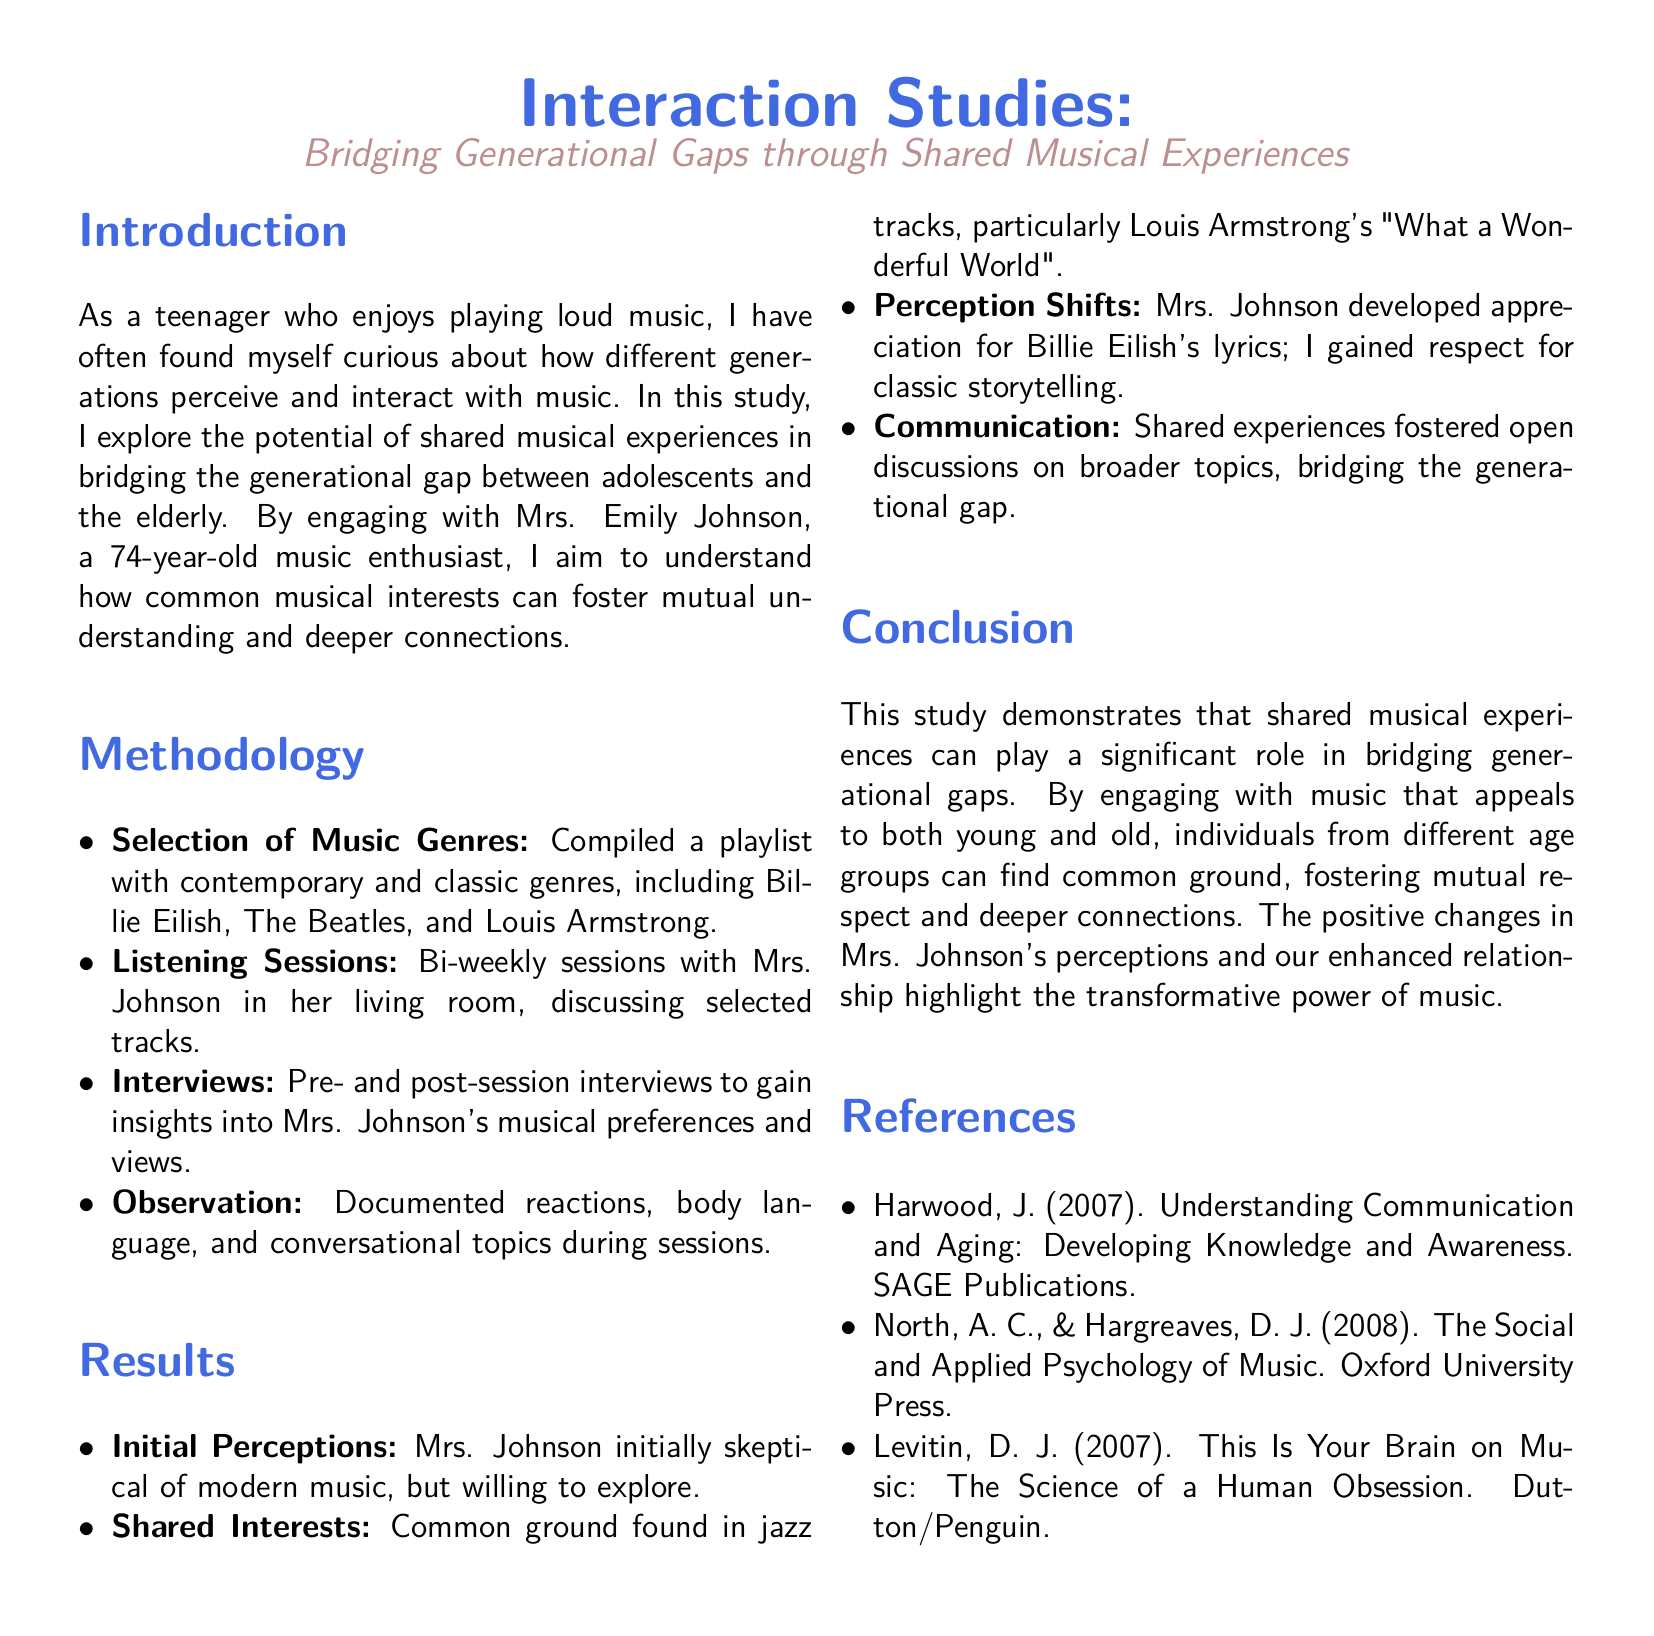What is the title of the study? The title is the main heading of the document and summarizes the focus of the research on music and generational gaps.
Answer: Interaction Studies: Bridging Generational Gaps through Shared Musical Experiences Who is the elderly woman the researcher engages with? The name is mentioned in the introduction section of the report, highlighting her importance in the study.
Answer: Mrs. Emily Johnson What genre of music initially raised skepticism? The document mentions the change in Mrs. Johnson's opinion regarding modern music, which began with skepticism.
Answer: Modern music What bi-weekly activity did the researcher conduct with Mrs. Johnson? This activity is outlined in the methodology section as a regular engagement to discuss music.
Answer: Listening Sessions What was a common track they found interest in? The results section specifies a particular song that bridged their musical preferences.
Answer: What a Wonderful World What is one positive outcome mentioned in the study? This conclusion reflects on the improvement in relationships and understanding based on shared music experiences.
Answer: Deeper connections How many references are included in the document? The references section shows the sources that supported the study, indicating academic rigor in the exploration.
Answer: Three What shift occurred in Mrs. Johnson's perception regarding Billie Eilish? This aspect of her changing views is highlighted in the results, regarding her acceptance of contemporary lyrics.
Answer: Appreciation What does the document claim music can significantly bridge? The conclusion emphasizes on what music fosters between different age groups, showcasing its socio-cultural effects.
Answer: Generational gaps 